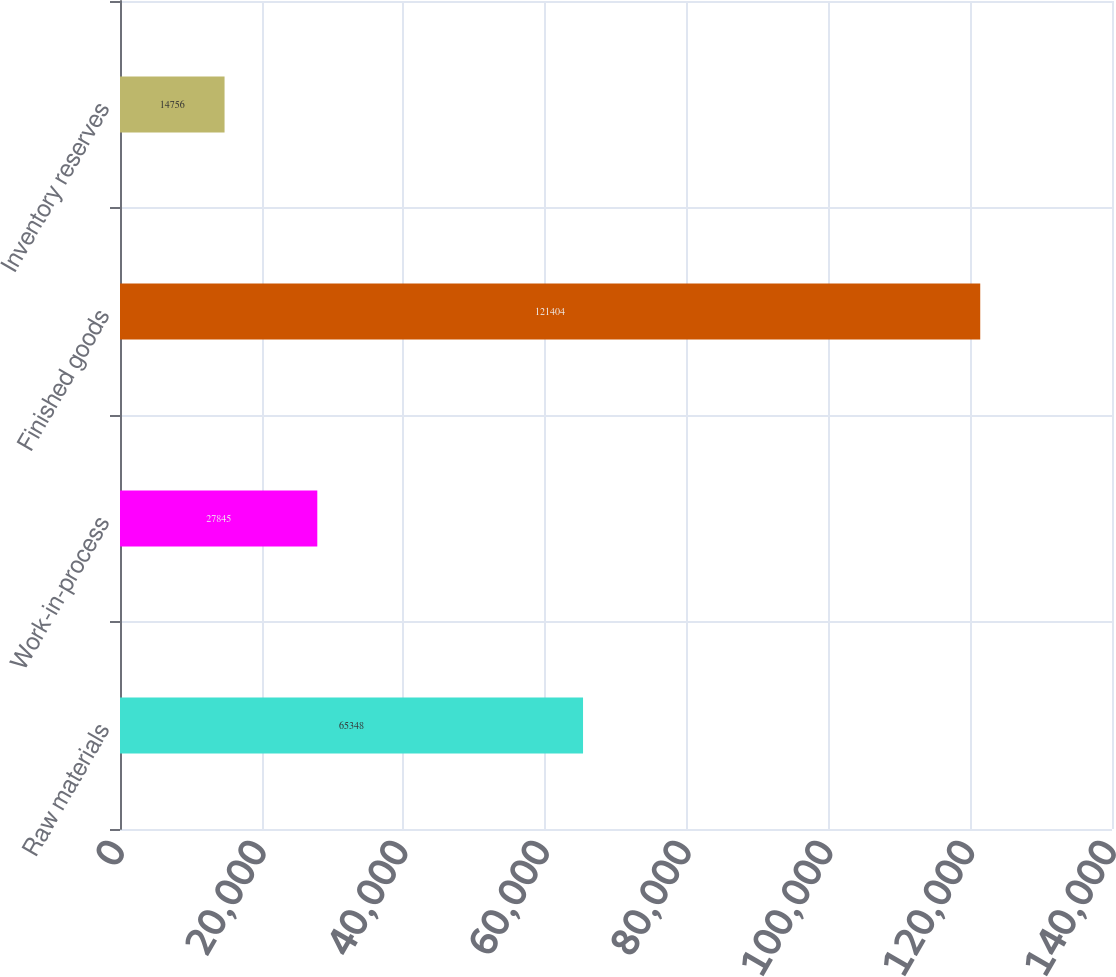Convert chart to OTSL. <chart><loc_0><loc_0><loc_500><loc_500><bar_chart><fcel>Raw materials<fcel>Work-in-process<fcel>Finished goods<fcel>Inventory reserves<nl><fcel>65348<fcel>27845<fcel>121404<fcel>14756<nl></chart> 